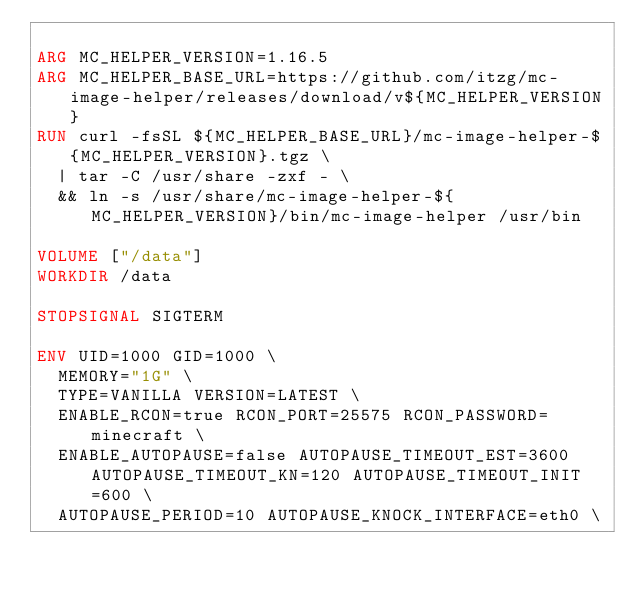<code> <loc_0><loc_0><loc_500><loc_500><_Dockerfile_>
ARG MC_HELPER_VERSION=1.16.5
ARG MC_HELPER_BASE_URL=https://github.com/itzg/mc-image-helper/releases/download/v${MC_HELPER_VERSION}
RUN curl -fsSL ${MC_HELPER_BASE_URL}/mc-image-helper-${MC_HELPER_VERSION}.tgz \
  | tar -C /usr/share -zxf - \
  && ln -s /usr/share/mc-image-helper-${MC_HELPER_VERSION}/bin/mc-image-helper /usr/bin

VOLUME ["/data"]
WORKDIR /data

STOPSIGNAL SIGTERM

ENV UID=1000 GID=1000 \
  MEMORY="1G" \
  TYPE=VANILLA VERSION=LATEST \
  ENABLE_RCON=true RCON_PORT=25575 RCON_PASSWORD=minecraft \
  ENABLE_AUTOPAUSE=false AUTOPAUSE_TIMEOUT_EST=3600 AUTOPAUSE_TIMEOUT_KN=120 AUTOPAUSE_TIMEOUT_INIT=600 \
  AUTOPAUSE_PERIOD=10 AUTOPAUSE_KNOCK_INTERFACE=eth0 \</code> 